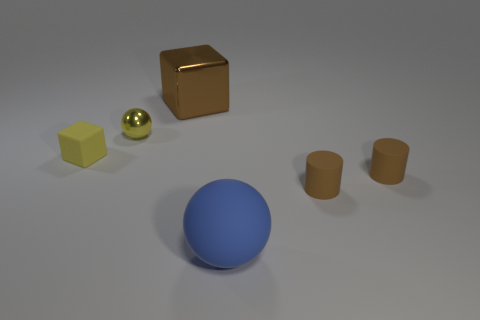What materials do the objects in the image appear to be made of? The objects present varied characteristics suggesting different materials. The large cube has a glossy, reflective surface that implies a metallic texture. The small yellow ball also has a metallic sheen, while the blue sphere seems to have a matte finish, possibly indicating a plastic or rubber composition. Finally, the cylinders appear to have a matte finish that could resemble a clay or stone material. 